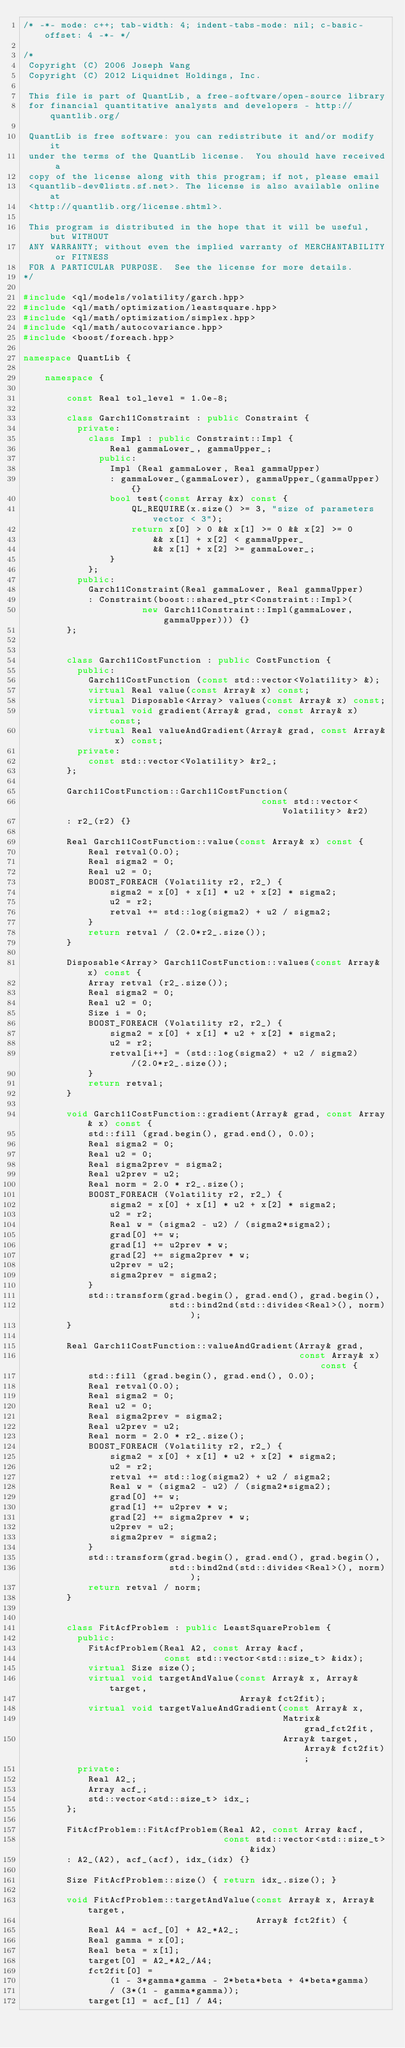Convert code to text. <code><loc_0><loc_0><loc_500><loc_500><_C++_>/* -*- mode: c++; tab-width: 4; indent-tabs-mode: nil; c-basic-offset: 4 -*- */

/*
 Copyright (C) 2006 Joseph Wang
 Copyright (C) 2012 Liquidnet Holdings, Inc.

 This file is part of QuantLib, a free-software/open-source library
 for financial quantitative analysts and developers - http://quantlib.org/

 QuantLib is free software: you can redistribute it and/or modify it
 under the terms of the QuantLib license.  You should have received a
 copy of the license along with this program; if not, please email
 <quantlib-dev@lists.sf.net>. The license is also available online at
 <http://quantlib.org/license.shtml>.

 This program is distributed in the hope that it will be useful, but WITHOUT
 ANY WARRANTY; without even the implied warranty of MERCHANTABILITY or FITNESS
 FOR A PARTICULAR PURPOSE.  See the license for more details.
*/

#include <ql/models/volatility/garch.hpp>
#include <ql/math/optimization/leastsquare.hpp>
#include <ql/math/optimization/simplex.hpp>
#include <ql/math/autocovariance.hpp>
#include <boost/foreach.hpp>

namespace QuantLib {

    namespace {

        const Real tol_level = 1.0e-8;

        class Garch11Constraint : public Constraint {
          private:
            class Impl : public Constraint::Impl {
                Real gammaLower_, gammaUpper_;
              public:
                Impl (Real gammaLower, Real gammaUpper)
                : gammaLower_(gammaLower), gammaUpper_(gammaUpper) {}
                bool test(const Array &x) const {
                    QL_REQUIRE(x.size() >= 3, "size of parameters vector < 3");
                    return x[0] > 0 && x[1] >= 0 && x[2] >= 0
                        && x[1] + x[2] < gammaUpper_
                        && x[1] + x[2] >= gammaLower_;
                }
            };
          public:
            Garch11Constraint(Real gammaLower, Real gammaUpper)
            : Constraint(boost::shared_ptr<Constraint::Impl>(
                      new Garch11Constraint::Impl(gammaLower, gammaUpper))) {}
        };


        class Garch11CostFunction : public CostFunction {
          public:
            Garch11CostFunction (const std::vector<Volatility> &);
            virtual Real value(const Array& x) const;
            virtual Disposable<Array> values(const Array& x) const;
            virtual void gradient(Array& grad, const Array& x) const;
            virtual Real valueAndGradient(Array& grad, const Array& x) const;
          private:
            const std::vector<Volatility> &r2_;
        };

        Garch11CostFunction::Garch11CostFunction(
                                            const std::vector<Volatility> &r2)
        : r2_(r2) {}

        Real Garch11CostFunction::value(const Array& x) const {
            Real retval(0.0);
            Real sigma2 = 0;
            Real u2 = 0;
            BOOST_FOREACH (Volatility r2, r2_) {
                sigma2 = x[0] + x[1] * u2 + x[2] * sigma2;
                u2 = r2;
                retval += std::log(sigma2) + u2 / sigma2;
            }
            return retval / (2.0*r2_.size());
        }

        Disposable<Array> Garch11CostFunction::values(const Array& x) const {
            Array retval (r2_.size());
            Real sigma2 = 0;
            Real u2 = 0;
            Size i = 0;
            BOOST_FOREACH (Volatility r2, r2_) {
                sigma2 = x[0] + x[1] * u2 + x[2] * sigma2;
                u2 = r2;
                retval[i++] = (std::log(sigma2) + u2 / sigma2)/(2.0*r2_.size());
            }
            return retval;
        }

        void Garch11CostFunction::gradient(Array& grad, const Array& x) const {
            std::fill (grad.begin(), grad.end(), 0.0);
            Real sigma2 = 0;
            Real u2 = 0;
            Real sigma2prev = sigma2;
            Real u2prev = u2;
            Real norm = 2.0 * r2_.size();
            BOOST_FOREACH (Volatility r2, r2_) {
                sigma2 = x[0] + x[1] * u2 + x[2] * sigma2;
                u2 = r2;
                Real w = (sigma2 - u2) / (sigma2*sigma2);
                grad[0] += w;
                grad[1] += u2prev * w;
                grad[2] += sigma2prev * w;
                u2prev = u2;
                sigma2prev = sigma2;
            }
            std::transform(grad.begin(), grad.end(), grad.begin(),
                           std::bind2nd(std::divides<Real>(), norm));
        }

        Real Garch11CostFunction::valueAndGradient(Array& grad,
                                                   const Array& x) const {
            std::fill (grad.begin(), grad.end(), 0.0);
            Real retval(0.0);
            Real sigma2 = 0;
            Real u2 = 0;
            Real sigma2prev = sigma2;
            Real u2prev = u2;
            Real norm = 2.0 * r2_.size();
            BOOST_FOREACH (Volatility r2, r2_) {
                sigma2 = x[0] + x[1] * u2 + x[2] * sigma2;
                u2 = r2;
                retval += std::log(sigma2) + u2 / sigma2;
                Real w = (sigma2 - u2) / (sigma2*sigma2);
                grad[0] += w;
                grad[1] += u2prev * w;
                grad[2] += sigma2prev * w;
                u2prev = u2;
                sigma2prev = sigma2;
            }
            std::transform(grad.begin(), grad.end(), grad.begin(),
                           std::bind2nd(std::divides<Real>(), norm));
            return retval / norm;
        }


        class FitAcfProblem : public LeastSquareProblem {
          public:
            FitAcfProblem(Real A2, const Array &acf,
                          const std::vector<std::size_t> &idx);
            virtual Size size();
            virtual void targetAndValue(const Array& x, Array& target,
                                        Array& fct2fit);
            virtual void targetValueAndGradient(const Array& x,
                                                Matrix& grad_fct2fit,
                                                Array& target, Array& fct2fit);
          private:
            Real A2_;
            Array acf_;
            std::vector<std::size_t> idx_;
        };

        FitAcfProblem::FitAcfProblem(Real A2, const Array &acf,
                                     const std::vector<std::size_t> &idx)
        : A2_(A2), acf_(acf), idx_(idx) {}

        Size FitAcfProblem::size() { return idx_.size(); }

        void FitAcfProblem::targetAndValue(const Array& x, Array& target,
                                           Array& fct2fit) {
            Real A4 = acf_[0] + A2_*A2_;
            Real gamma = x[0];
            Real beta = x[1];
            target[0] = A2_*A2_/A4;
            fct2fit[0] =
                (1 - 3*gamma*gamma - 2*beta*beta + 4*beta*gamma)
                / (3*(1 - gamma*gamma));
            target[1] = acf_[1] / A4;</code> 